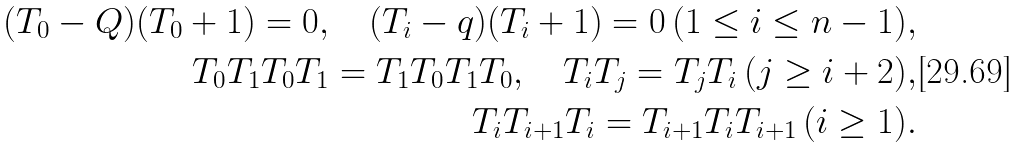Convert formula to latex. <formula><loc_0><loc_0><loc_500><loc_500>( T _ { 0 } - Q ) ( T _ { 0 } + 1 ) = 0 , \quad ( T _ { i } - q ) ( T _ { i } + 1 ) = 0 \, ( 1 \leq i \leq n - 1 ) , \\ T _ { 0 } T _ { 1 } T _ { 0 } T _ { 1 } = T _ { 1 } T _ { 0 } T _ { 1 } T _ { 0 } , \quad T _ { i } T _ { j } = T _ { j } T _ { i } \, ( j \geq i + 2 ) , \\ T _ { i } T _ { i + 1 } T _ { i } = T _ { i + 1 } T _ { i } T _ { i + 1 } \, ( i \geq 1 ) .</formula> 